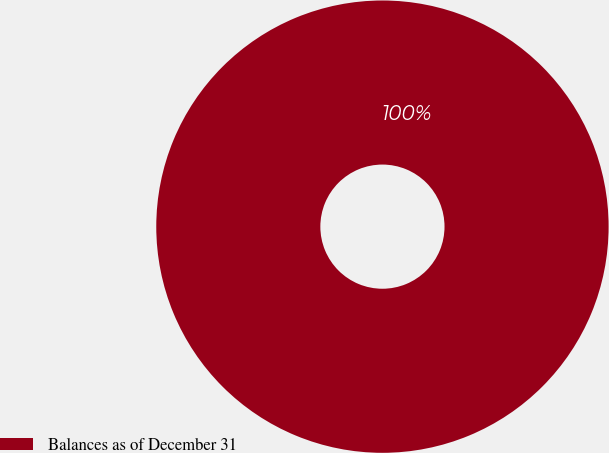<chart> <loc_0><loc_0><loc_500><loc_500><pie_chart><fcel>Balances as of December 31<nl><fcel>100.0%<nl></chart> 